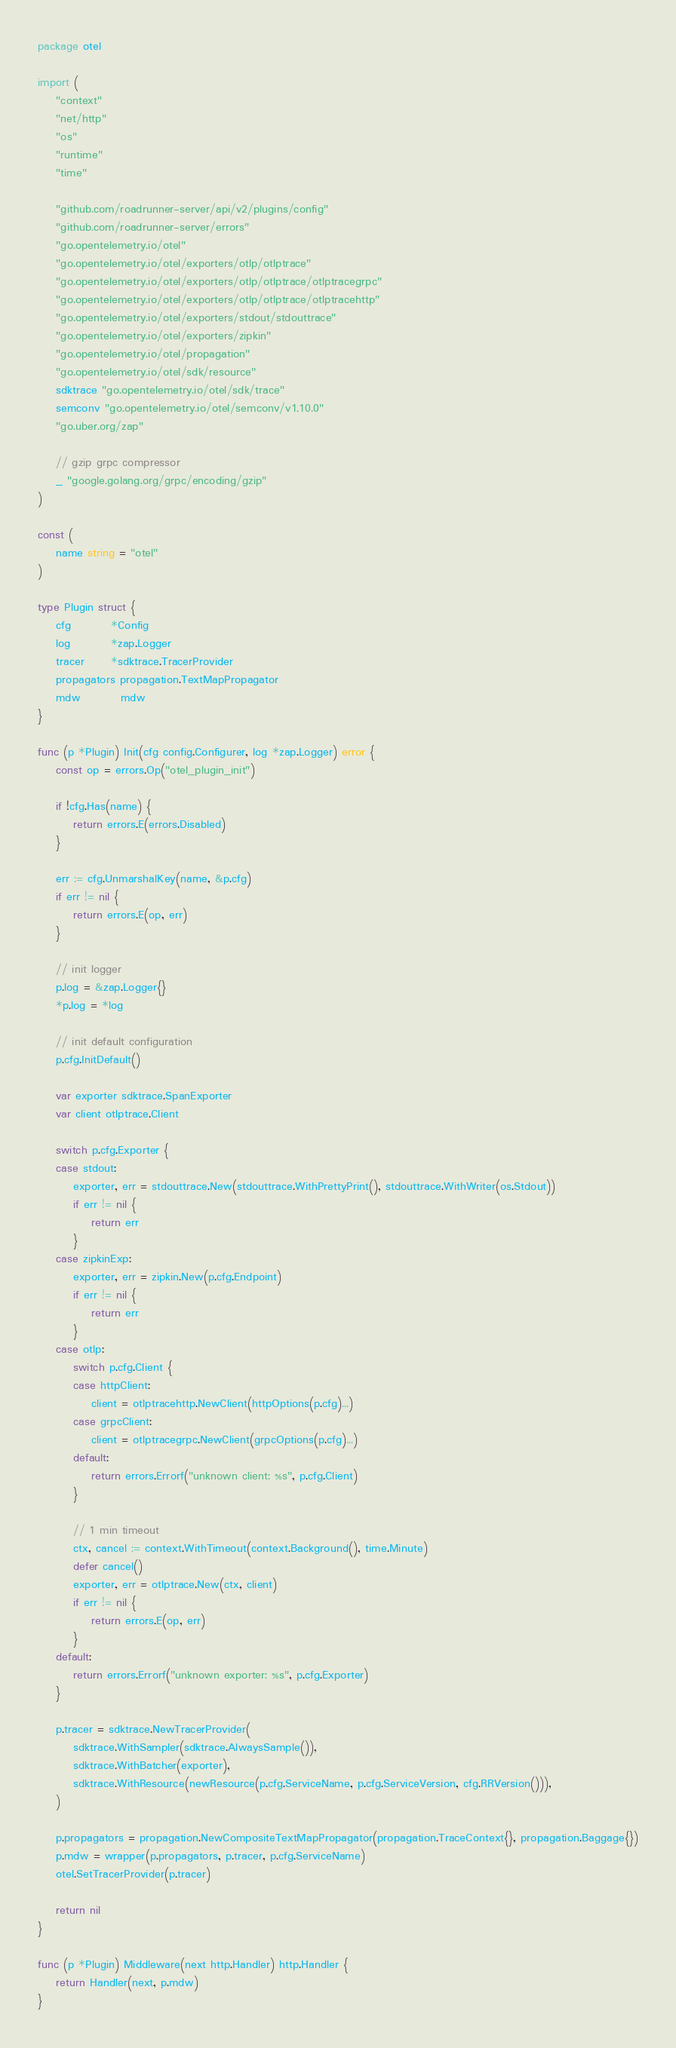Convert code to text. <code><loc_0><loc_0><loc_500><loc_500><_Go_>package otel

import (
	"context"
	"net/http"
	"os"
	"runtime"
	"time"

	"github.com/roadrunner-server/api/v2/plugins/config"
	"github.com/roadrunner-server/errors"
	"go.opentelemetry.io/otel"
	"go.opentelemetry.io/otel/exporters/otlp/otlptrace"
	"go.opentelemetry.io/otel/exporters/otlp/otlptrace/otlptracegrpc"
	"go.opentelemetry.io/otel/exporters/otlp/otlptrace/otlptracehttp"
	"go.opentelemetry.io/otel/exporters/stdout/stdouttrace"
	"go.opentelemetry.io/otel/exporters/zipkin"
	"go.opentelemetry.io/otel/propagation"
	"go.opentelemetry.io/otel/sdk/resource"
	sdktrace "go.opentelemetry.io/otel/sdk/trace"
	semconv "go.opentelemetry.io/otel/semconv/v1.10.0"
	"go.uber.org/zap"

	// gzip grpc compressor
	_ "google.golang.org/grpc/encoding/gzip"
)

const (
	name string = "otel"
)

type Plugin struct {
	cfg         *Config
	log         *zap.Logger
	tracer      *sdktrace.TracerProvider
	propagators propagation.TextMapPropagator
	mdw         mdw
}

func (p *Plugin) Init(cfg config.Configurer, log *zap.Logger) error {
	const op = errors.Op("otel_plugin_init")

	if !cfg.Has(name) {
		return errors.E(errors.Disabled)
	}

	err := cfg.UnmarshalKey(name, &p.cfg)
	if err != nil {
		return errors.E(op, err)
	}

	// init logger
	p.log = &zap.Logger{}
	*p.log = *log

	// init default configuration
	p.cfg.InitDefault()

	var exporter sdktrace.SpanExporter
	var client otlptrace.Client

	switch p.cfg.Exporter {
	case stdout:
		exporter, err = stdouttrace.New(stdouttrace.WithPrettyPrint(), stdouttrace.WithWriter(os.Stdout))
		if err != nil {
			return err
		}
	case zipkinExp:
		exporter, err = zipkin.New(p.cfg.Endpoint)
		if err != nil {
			return err
		}
	case otlp:
		switch p.cfg.Client {
		case httpClient:
			client = otlptracehttp.NewClient(httpOptions(p.cfg)...)
		case grpcClient:
			client = otlptracegrpc.NewClient(grpcOptions(p.cfg)...)
		default:
			return errors.Errorf("unknown client: %s", p.cfg.Client)
		}

		// 1 min timeout
		ctx, cancel := context.WithTimeout(context.Background(), time.Minute)
		defer cancel()
		exporter, err = otlptrace.New(ctx, client)
		if err != nil {
			return errors.E(op, err)
		}
	default:
		return errors.Errorf("unknown exporter: %s", p.cfg.Exporter)
	}

	p.tracer = sdktrace.NewTracerProvider(
		sdktrace.WithSampler(sdktrace.AlwaysSample()),
		sdktrace.WithBatcher(exporter),
		sdktrace.WithResource(newResource(p.cfg.ServiceName, p.cfg.ServiceVersion, cfg.RRVersion())),
	)

	p.propagators = propagation.NewCompositeTextMapPropagator(propagation.TraceContext{}, propagation.Baggage{})
	p.mdw = wrapper(p.propagators, p.tracer, p.cfg.ServiceName)
	otel.SetTracerProvider(p.tracer)

	return nil
}

func (p *Plugin) Middleware(next http.Handler) http.Handler {
	return Handler(next, p.mdw)
}
</code> 